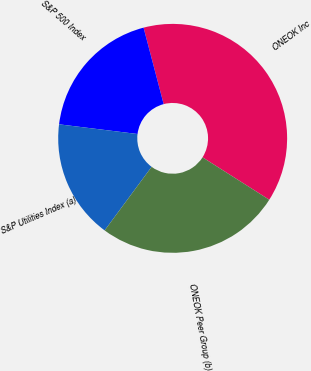Convert chart to OTSL. <chart><loc_0><loc_0><loc_500><loc_500><pie_chart><fcel>ONEOK Inc<fcel>S&P 500 Index<fcel>S&P Utilities Index (a)<fcel>ONEOK Peer Group (b)<nl><fcel>38.1%<fcel>18.95%<fcel>16.83%<fcel>26.11%<nl></chart> 